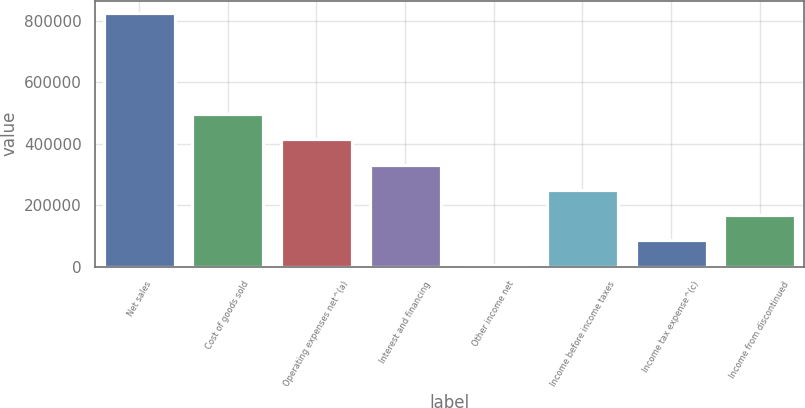Convert chart to OTSL. <chart><loc_0><loc_0><loc_500><loc_500><bar_chart><fcel>Net sales<fcel>Cost of goods sold<fcel>Operating expenses net^(a)<fcel>Interest and financing<fcel>Other income net<fcel>Income before income taxes<fcel>Income tax expense^(c)<fcel>Income from discontinued<nl><fcel>824906<fcel>496629<fcel>414560<fcel>332491<fcel>4214<fcel>250422<fcel>86283.2<fcel>168352<nl></chart> 